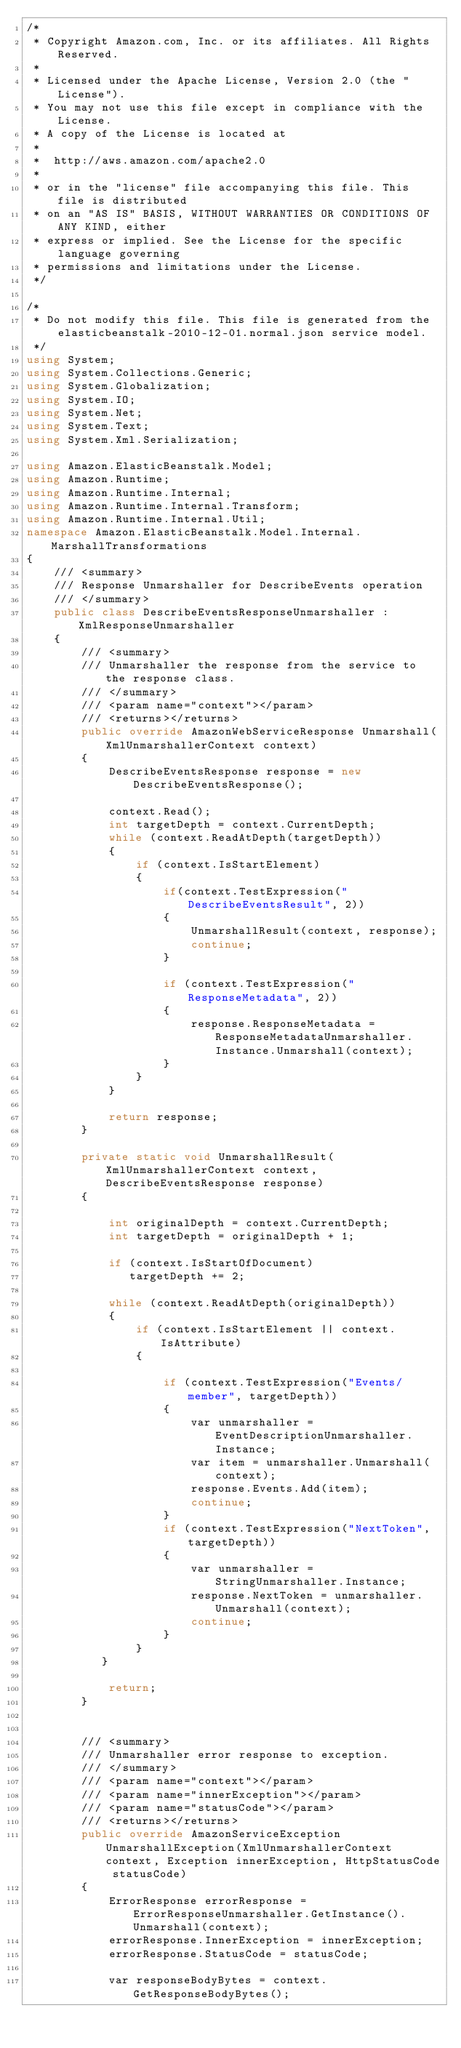Convert code to text. <code><loc_0><loc_0><loc_500><loc_500><_C#_>/*
 * Copyright Amazon.com, Inc. or its affiliates. All Rights Reserved.
 * 
 * Licensed under the Apache License, Version 2.0 (the "License").
 * You may not use this file except in compliance with the License.
 * A copy of the License is located at
 * 
 *  http://aws.amazon.com/apache2.0
 * 
 * or in the "license" file accompanying this file. This file is distributed
 * on an "AS IS" BASIS, WITHOUT WARRANTIES OR CONDITIONS OF ANY KIND, either
 * express or implied. See the License for the specific language governing
 * permissions and limitations under the License.
 */

/*
 * Do not modify this file. This file is generated from the elasticbeanstalk-2010-12-01.normal.json service model.
 */
using System;
using System.Collections.Generic;
using System.Globalization;
using System.IO;
using System.Net;
using System.Text;
using System.Xml.Serialization;

using Amazon.ElasticBeanstalk.Model;
using Amazon.Runtime;
using Amazon.Runtime.Internal;
using Amazon.Runtime.Internal.Transform;
using Amazon.Runtime.Internal.Util;
namespace Amazon.ElasticBeanstalk.Model.Internal.MarshallTransformations
{
    /// <summary>
    /// Response Unmarshaller for DescribeEvents operation
    /// </summary>  
    public class DescribeEventsResponseUnmarshaller : XmlResponseUnmarshaller
    {
        /// <summary>
        /// Unmarshaller the response from the service to the response class.
        /// </summary>  
        /// <param name="context"></param>
        /// <returns></returns>
        public override AmazonWebServiceResponse Unmarshall(XmlUnmarshallerContext context)
        {
            DescribeEventsResponse response = new DescribeEventsResponse();

            context.Read();
            int targetDepth = context.CurrentDepth;
            while (context.ReadAtDepth(targetDepth))
            {
                if (context.IsStartElement)
                {                    
                    if(context.TestExpression("DescribeEventsResult", 2))
                    {
                        UnmarshallResult(context, response);                        
                        continue;
                    }
                    
                    if (context.TestExpression("ResponseMetadata", 2))
                    {
                        response.ResponseMetadata = ResponseMetadataUnmarshaller.Instance.Unmarshall(context);
                    }
                }
            }

            return response;
        }

        private static void UnmarshallResult(XmlUnmarshallerContext context, DescribeEventsResponse response)
        {
            
            int originalDepth = context.CurrentDepth;
            int targetDepth = originalDepth + 1;
            
            if (context.IsStartOfDocument) 
               targetDepth += 2;
            
            while (context.ReadAtDepth(originalDepth))
            {
                if (context.IsStartElement || context.IsAttribute)
                {

                    if (context.TestExpression("Events/member", targetDepth))
                    {
                        var unmarshaller = EventDescriptionUnmarshaller.Instance;
                        var item = unmarshaller.Unmarshall(context);
                        response.Events.Add(item);
                        continue;
                    }
                    if (context.TestExpression("NextToken", targetDepth))
                    {
                        var unmarshaller = StringUnmarshaller.Instance;
                        response.NextToken = unmarshaller.Unmarshall(context);
                        continue;
                    }
                } 
           }

            return;
        }


        /// <summary>
        /// Unmarshaller error response to exception.
        /// </summary>  
        /// <param name="context"></param>
        /// <param name="innerException"></param>
        /// <param name="statusCode"></param>
        /// <returns></returns>
        public override AmazonServiceException UnmarshallException(XmlUnmarshallerContext context, Exception innerException, HttpStatusCode statusCode)
        {
            ErrorResponse errorResponse = ErrorResponseUnmarshaller.GetInstance().Unmarshall(context);
            errorResponse.InnerException = innerException;
            errorResponse.StatusCode = statusCode;

            var responseBodyBytes = context.GetResponseBodyBytes();
</code> 